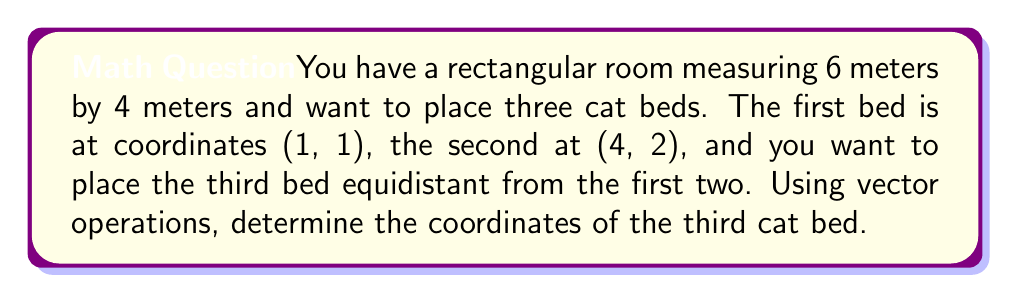What is the answer to this math problem? Let's approach this step-by-step:

1) First, let's define our vectors:
   $\vec{a} = (1, 1)$ for the first cat bed
   $\vec{b} = (4, 2)$ for the second cat bed

2) To find the midpoint between these two beds, we can use the vector operation:
   $\vec{m} = \frac{1}{2}(\vec{a} + \vec{b})$

3) Let's calculate this:
   $\vec{m} = \frac{1}{2}((1, 1) + (4, 2))$
   $\vec{m} = \frac{1}{2}(5, 3)$
   $\vec{m} = (2.5, 1.5)$

4) The coordinates (2.5, 1.5) represent the location of the third cat bed that is equidistant from the first two.

5) To verify, we can calculate the distance from this point to each of the original beds:

   Distance to $\vec{a}$: 
   $d_a = \sqrt{(2.5-1)^2 + (1.5-1)^2} = \sqrt{2.25 + 0.25} = \sqrt{2.5}$

   Distance to $\vec{b}$:
   $d_b = \sqrt{(4-2.5)^2 + (2-1.5)^2} = \sqrt{2.25 + 0.25} = \sqrt{2.5}$

   As both distances are equal, our calculation is correct.
Answer: $(2.5, 1.5)$ 